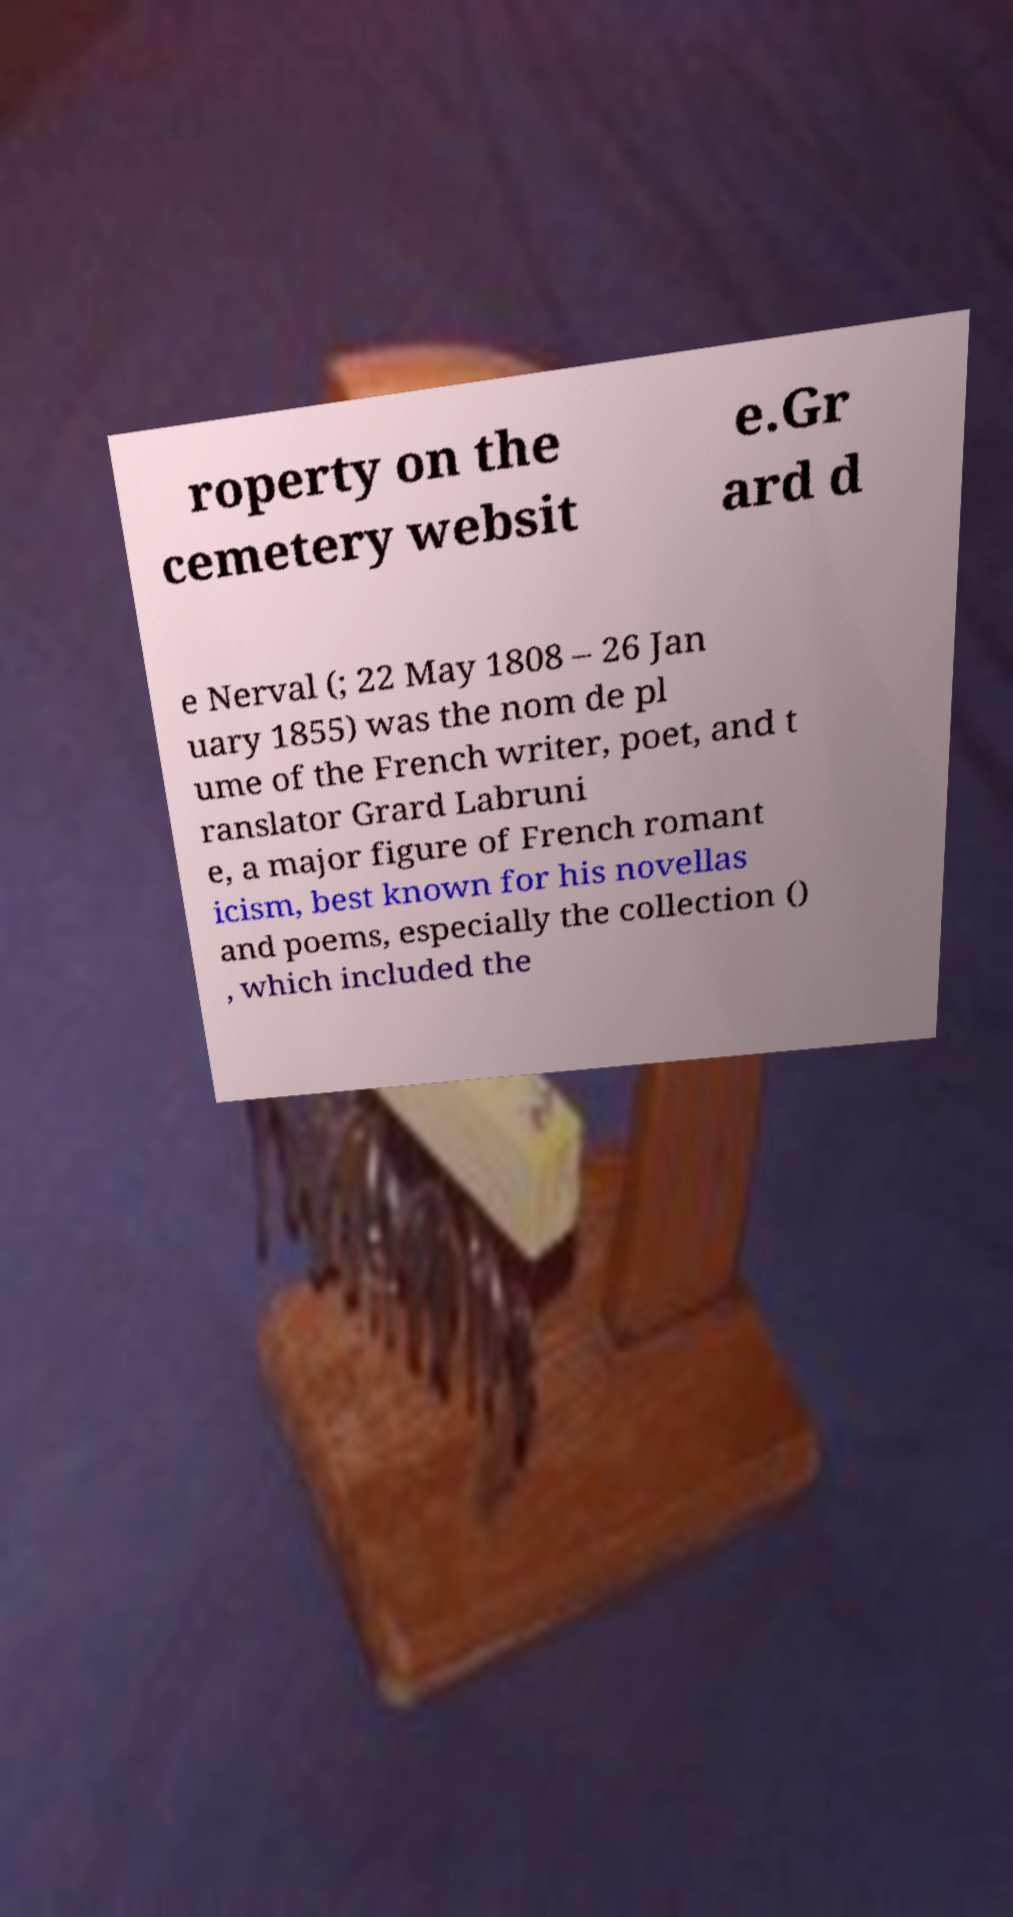Could you extract and type out the text from this image? roperty on the cemetery websit e.Gr ard d e Nerval (; 22 May 1808 – 26 Jan uary 1855) was the nom de pl ume of the French writer, poet, and t ranslator Grard Labruni e, a major figure of French romant icism, best known for his novellas and poems, especially the collection () , which included the 